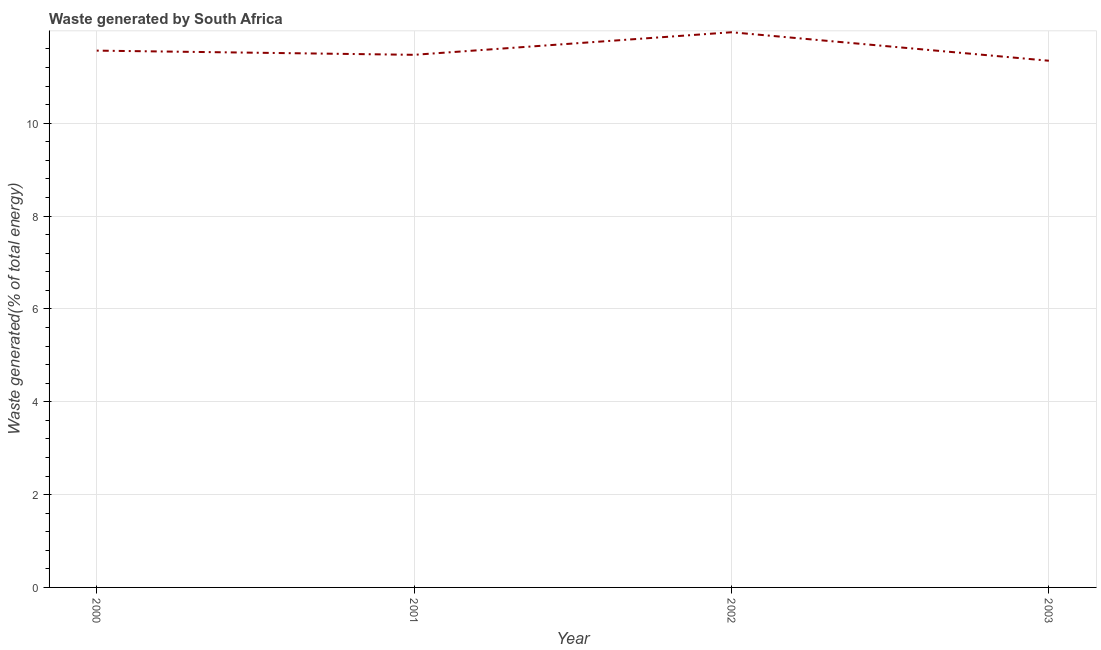What is the amount of waste generated in 2002?
Provide a short and direct response. 11.96. Across all years, what is the maximum amount of waste generated?
Offer a terse response. 11.96. Across all years, what is the minimum amount of waste generated?
Keep it short and to the point. 11.35. What is the sum of the amount of waste generated?
Give a very brief answer. 46.34. What is the difference between the amount of waste generated in 2000 and 2002?
Your answer should be very brief. -0.4. What is the average amount of waste generated per year?
Offer a terse response. 11.59. What is the median amount of waste generated?
Provide a short and direct response. 11.52. In how many years, is the amount of waste generated greater than 0.8 %?
Your answer should be very brief. 4. Do a majority of the years between 2000 and 2002 (inclusive) have amount of waste generated greater than 2.8 %?
Offer a terse response. Yes. What is the ratio of the amount of waste generated in 2000 to that in 2002?
Your answer should be compact. 0.97. Is the amount of waste generated in 2000 less than that in 2001?
Your answer should be very brief. No. Is the difference between the amount of waste generated in 2001 and 2002 greater than the difference between any two years?
Provide a short and direct response. No. What is the difference between the highest and the second highest amount of waste generated?
Ensure brevity in your answer.  0.4. What is the difference between the highest and the lowest amount of waste generated?
Make the answer very short. 0.61. Does the amount of waste generated monotonically increase over the years?
Your response must be concise. No. How many lines are there?
Your response must be concise. 1. How many years are there in the graph?
Your response must be concise. 4. Does the graph contain any zero values?
Your answer should be very brief. No. What is the title of the graph?
Your response must be concise. Waste generated by South Africa. What is the label or title of the Y-axis?
Give a very brief answer. Waste generated(% of total energy). What is the Waste generated(% of total energy) of 2000?
Your response must be concise. 11.56. What is the Waste generated(% of total energy) in 2001?
Provide a succinct answer. 11.47. What is the Waste generated(% of total energy) in 2002?
Your response must be concise. 11.96. What is the Waste generated(% of total energy) of 2003?
Your answer should be compact. 11.35. What is the difference between the Waste generated(% of total energy) in 2000 and 2001?
Offer a very short reply. 0.09. What is the difference between the Waste generated(% of total energy) in 2000 and 2002?
Keep it short and to the point. -0.4. What is the difference between the Waste generated(% of total energy) in 2000 and 2003?
Offer a terse response. 0.22. What is the difference between the Waste generated(% of total energy) in 2001 and 2002?
Ensure brevity in your answer.  -0.49. What is the difference between the Waste generated(% of total energy) in 2001 and 2003?
Offer a very short reply. 0.13. What is the difference between the Waste generated(% of total energy) in 2002 and 2003?
Provide a succinct answer. 0.61. What is the ratio of the Waste generated(% of total energy) in 2000 to that in 2003?
Your response must be concise. 1.02. What is the ratio of the Waste generated(% of total energy) in 2001 to that in 2003?
Offer a terse response. 1.01. What is the ratio of the Waste generated(% of total energy) in 2002 to that in 2003?
Offer a terse response. 1.05. 